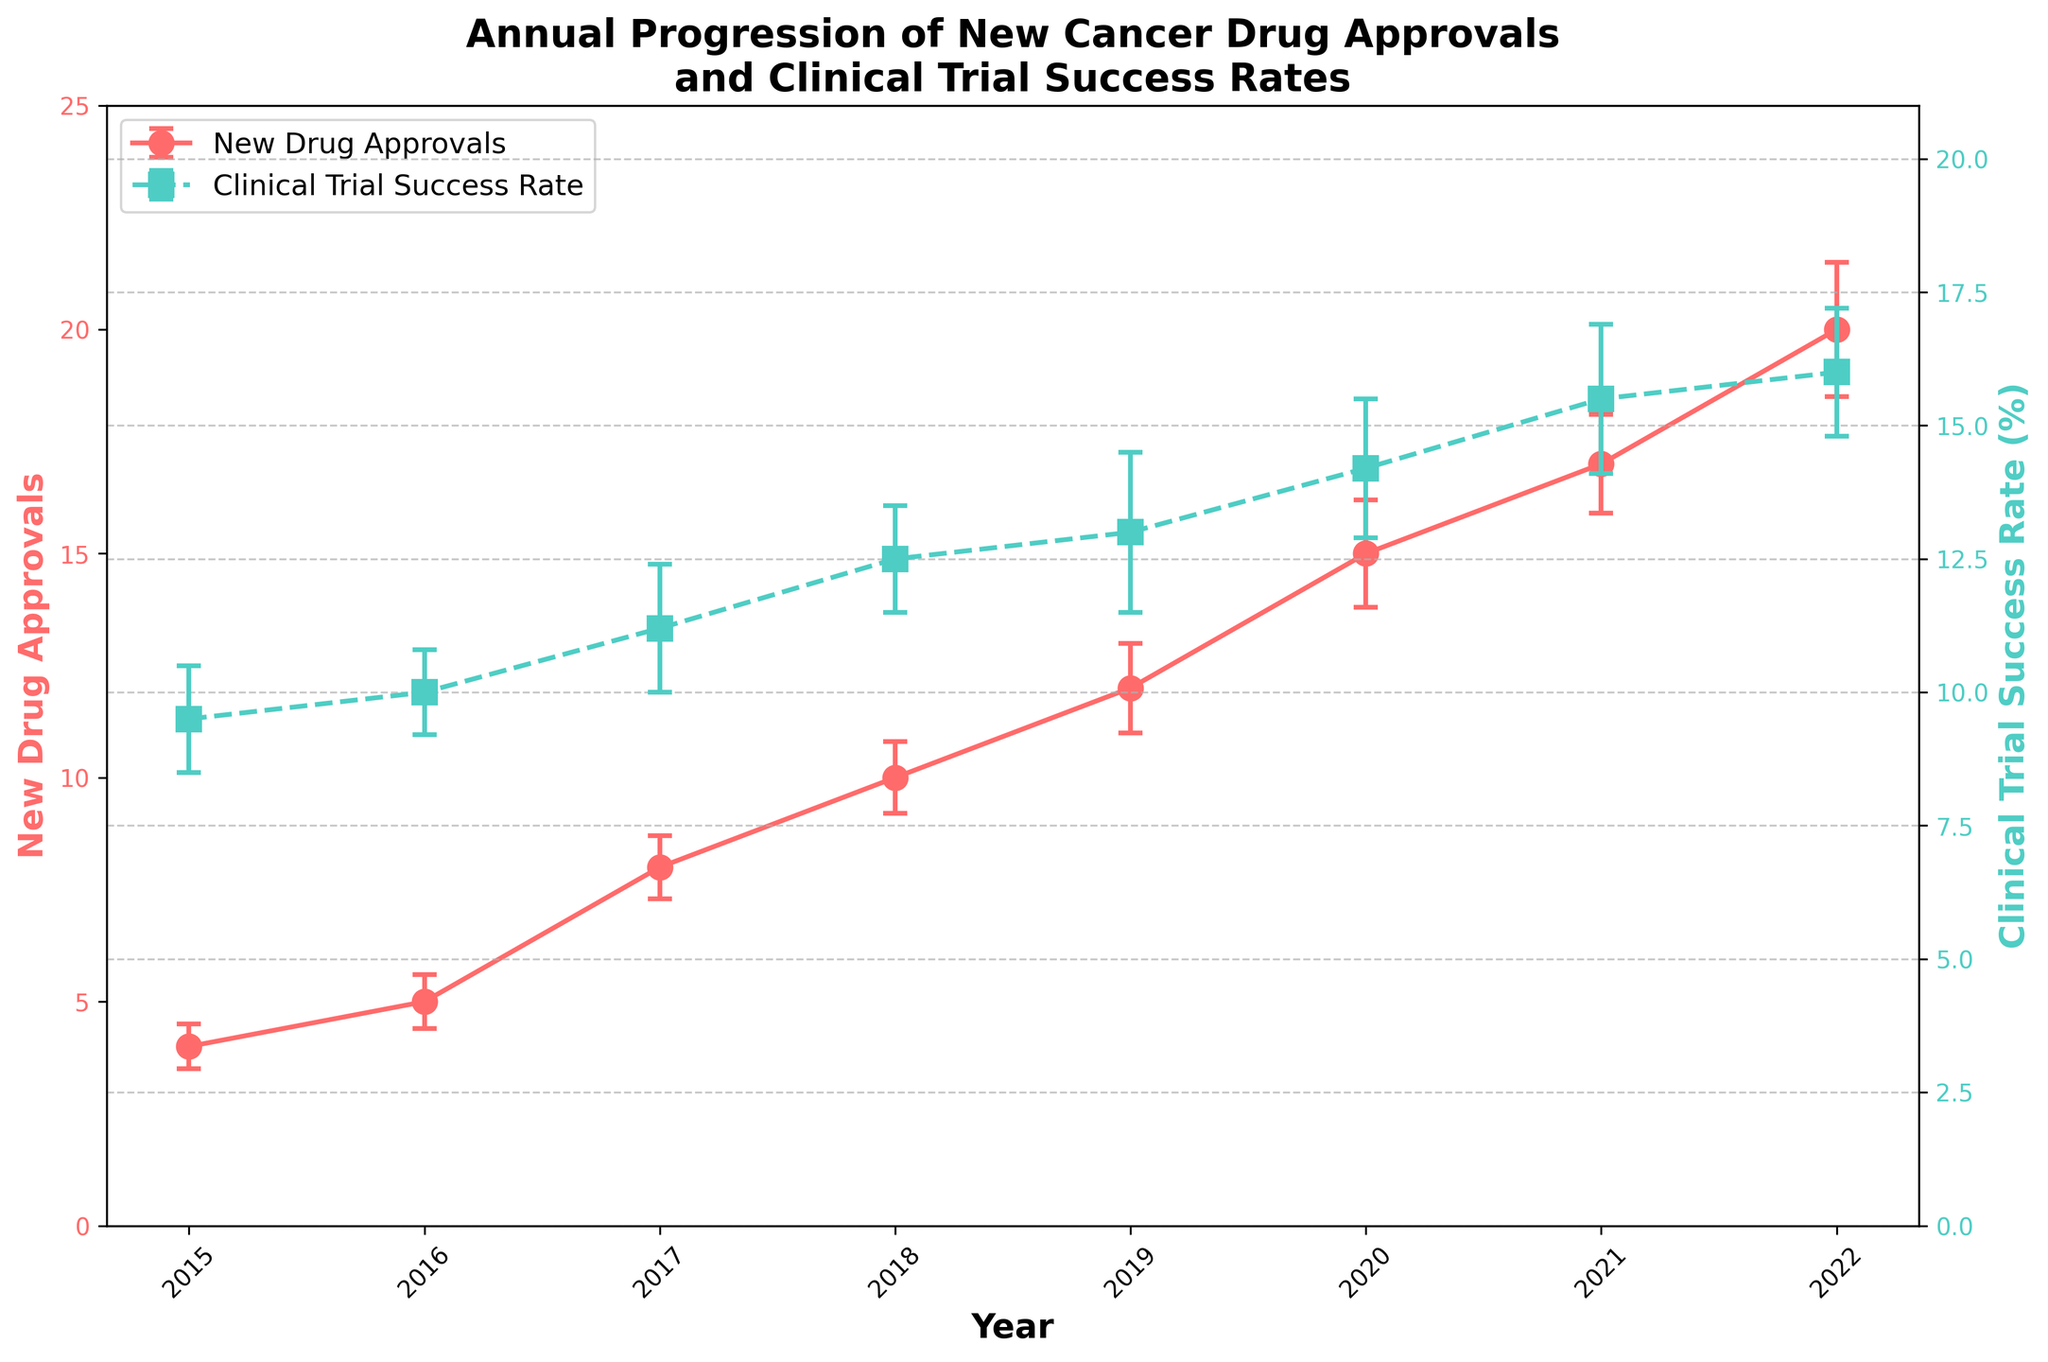What's the title of the chart? The chart title is usually at the top and describes the main topic of the figure. Reading the title helps understand the overall content at a glance.
Answer: Annual Progression of New Cancer Drug Approvals and Clinical Trial Success Rates What color represents New Drug Approvals? The color of the line or marker corresponding to New Drug Approvals can be determined by looking at the chart legend. This helps associate the data series with its visual representation.
Answer: Red How many new drug approvals were there in 2018? Locate the point corresponding to the year 2018 on the x-axis and read off the value on the y-axis for New Drug Approvals.
Answer: 10 How did the clinical trial success rate change from 2020 to 2021? Compare the y-values of the Clinical Trial Success Rate at 2020 and 2021. This involves checking their positions on the graph and calculating the difference.
Answer: Increased by 1.3% Which year had the highest number of new drug approvals? To find this, look for the peak value in the New Drug Approvals line plot and note the corresponding year on the x-axis.
Answer: 2022 What was the approximate success rate error in clinical trials for the year 2019? Identify the error bars for the Clinical Trial Success Rate in 2019. The error magnitude can be roughly estimated from the length of the error bars.
Answer: ±1.5% What is the overall trend in new drug approvals from 2015 to 2022? Examine the slope of the New Drug Approvals line plot over the years. A positive slope indicates an increasing trend while a negative slope indicates a decreasing trend.
Answer: Increasing Are the error bars larger for drug approvals or clinical trial success rates in 2022? Compare the length of the error bars for Drug Approvals and Clinical Trial Success Rates in 2022. This involves a visual inspection of the plot.
Answer: Drug Approvals Which had a higher value in 2017: New Drug Approvals or Clinical Trial Success Rate? Compare the y-values for both New Drug Approvals and Clinical Trial Success Rate at the year 2017 by checking their markers on the plot.
Answer: Clinical Trial Success Rate What is the average number of new drug approvals from 2015 to 2020? Sum the New Drug Approvals values from 2015 to 2020 and then divide by the number of years, which is 6. ((4 + 5 + 8 + 10 + 12 + 15) / 6 = 54 / 6 = 9)
Answer: 9 